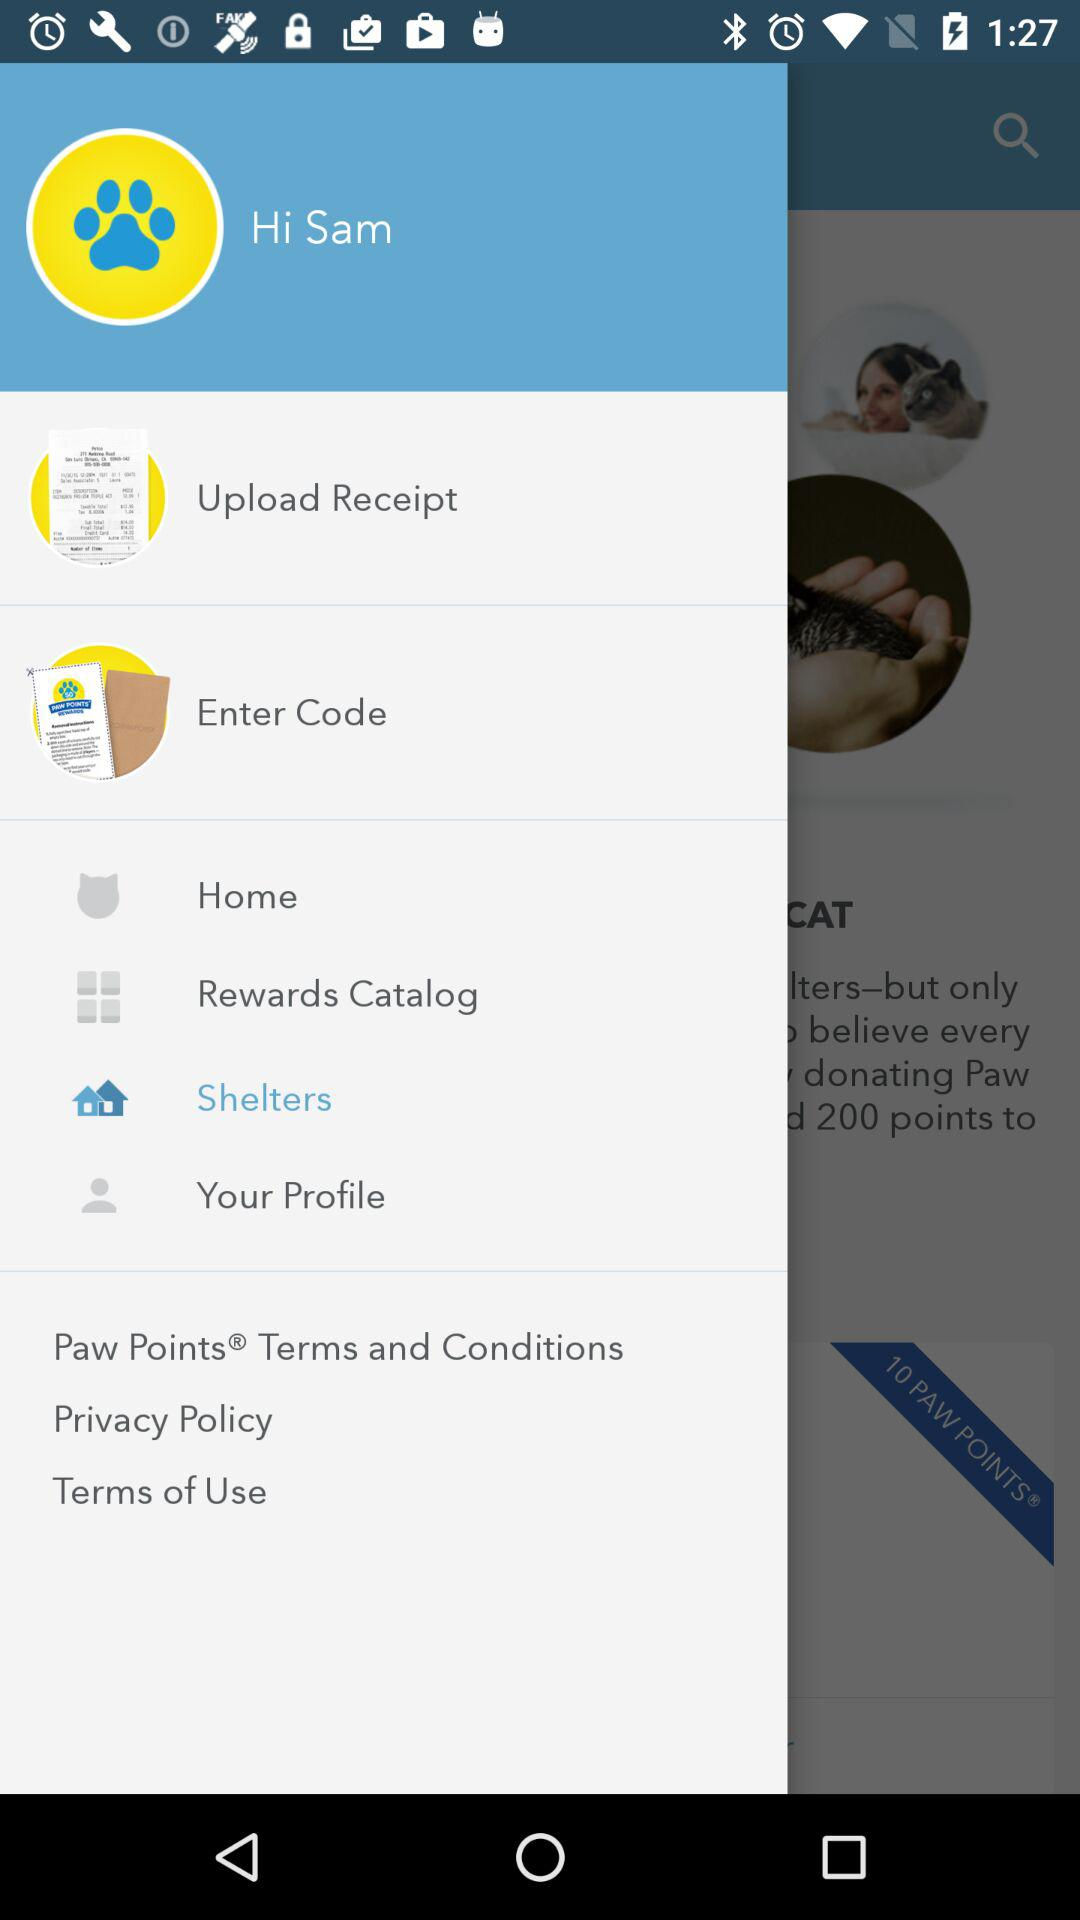How many points do you get for donating to a shelter?
Answer the question using a single word or phrase. 200 